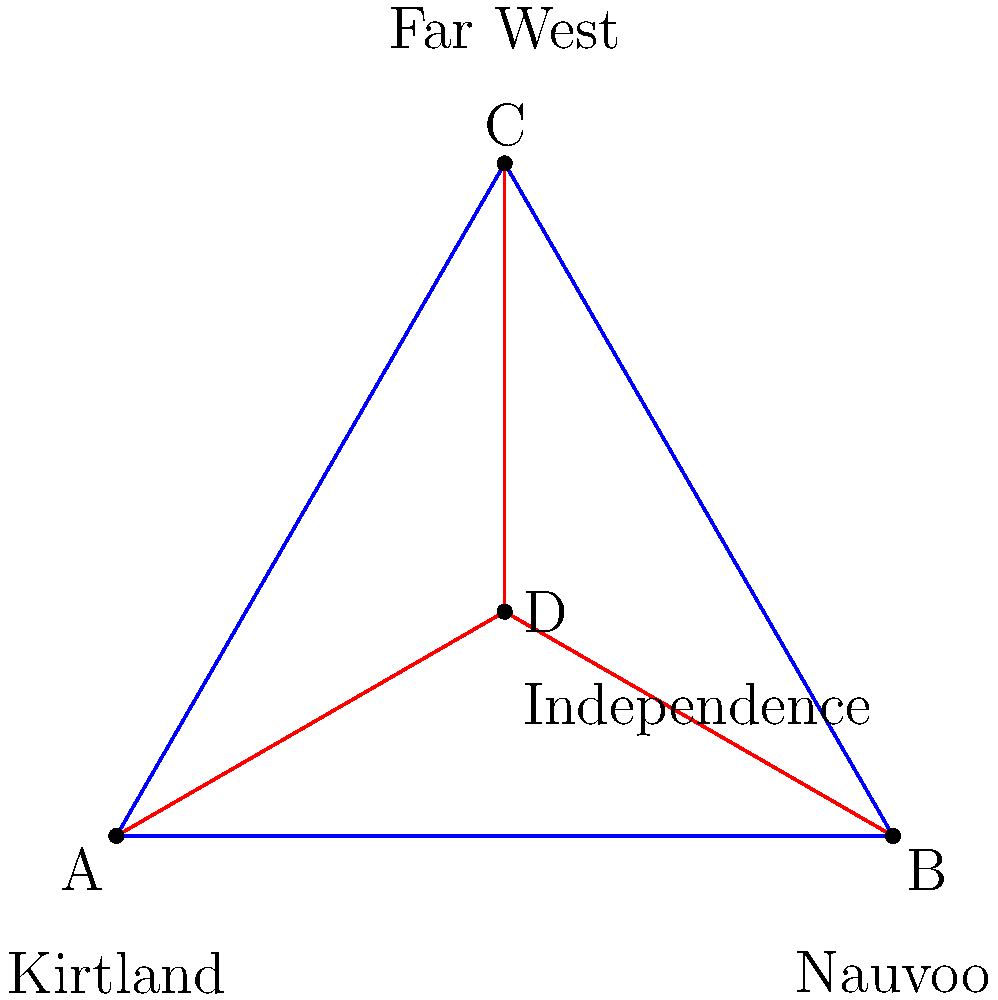The diagram represents the geographical layout of four significant early Mormon settlements: Kirtland, Nauvoo, Far West, and Independence. Which sacred geometry principle is most closely associated with this arrangement, and how does it relate to Mormon theology? To answer this question, let's analyze the diagram step-by-step:

1. The settlements form a triangle with Independence (D) at its center.

2. The triangle ABC is equilateral, as all sides appear equal.

3. Point D (Independence) is located at the centroid of the equilateral triangle.

4. In sacred geometry, this configuration is known as the Vesica Piscis, where:
   - The equilateral triangle represents the Trinity
   - The center point represents the point of creation or divine manifestation

5. In Mormon theology:
   - The equilateral triangle could symbolize the Godhead (Father, Son, and Holy Ghost)
   - Independence, Missouri, is considered the center place of Zion in Mormon doctrine

6. This arrangement aligns with the Mormon concept of the New Jerusalem or Zion, with Independence at its heart.

7. The geometric symmetry reflects the Mormon belief in divine order and the interconnectedness of earthly and heavenly realms.

Therefore, the sacred geometry principle most closely associated with this arrangement is the Vesica Piscis, which relates to Mormon theology through its representation of the Godhead and the centrality of Zion (Independence) in the plan of salvation.
Answer: Vesica Piscis 